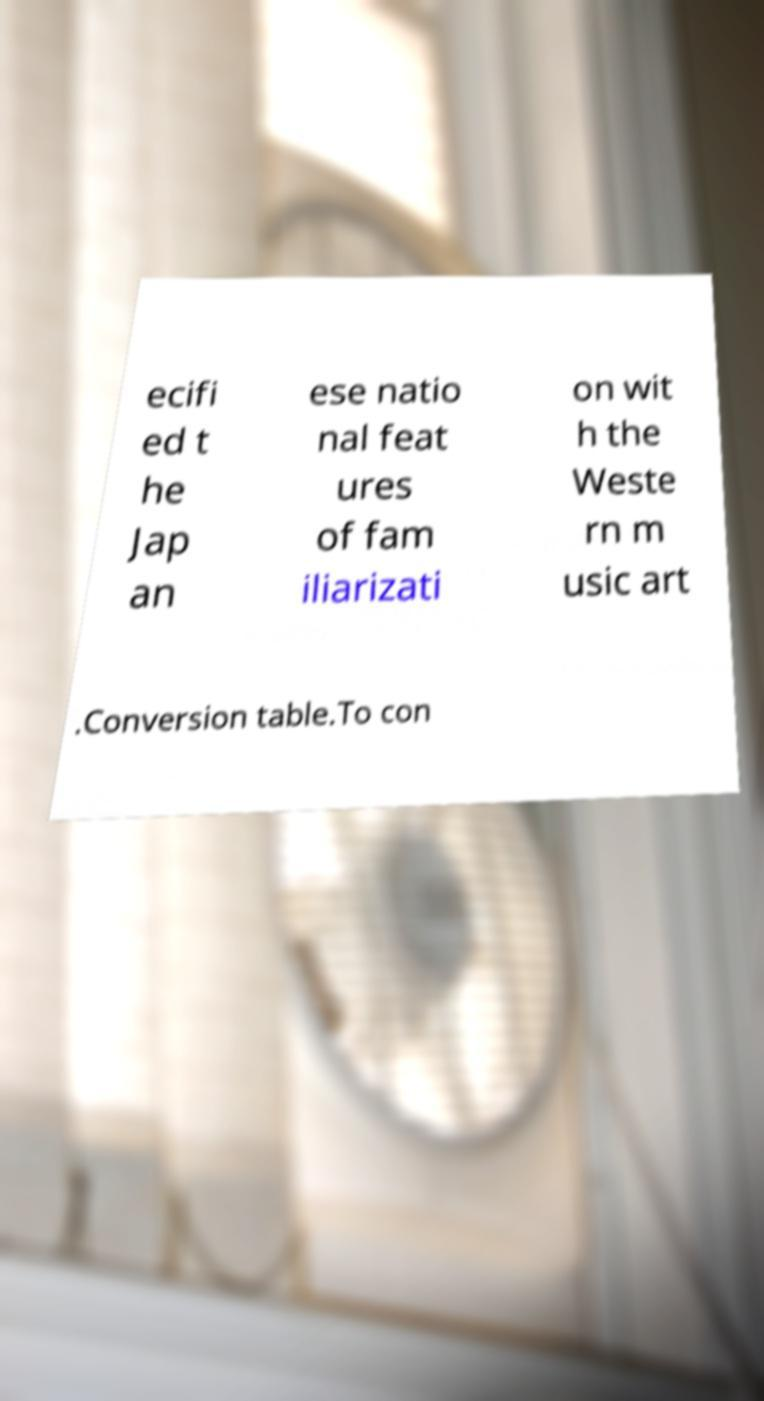I need the written content from this picture converted into text. Can you do that? ecifi ed t he Jap an ese natio nal feat ures of fam iliarizati on wit h the Weste rn m usic art .Conversion table.To con 